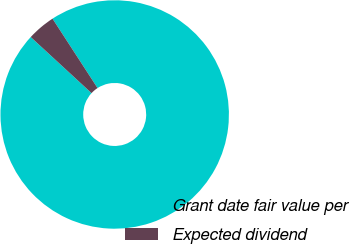<chart> <loc_0><loc_0><loc_500><loc_500><pie_chart><fcel>Grant date fair value per<fcel>Expected dividend<nl><fcel>96.02%<fcel>3.98%<nl></chart> 